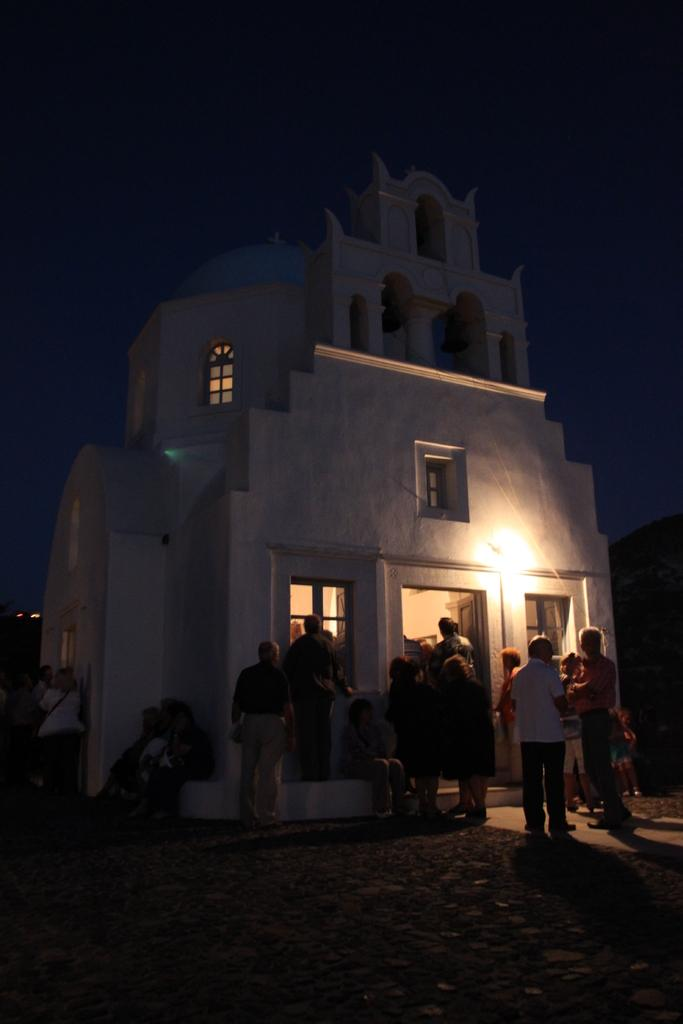What type of structure is in the image? There is a building in the image. What feature can be observed on the building? The building has glass windows. Who is present near the building? There are people standing outside the building. What other structure is near the people? The people are standing near a house. How would you describe the lighting in the image? The sky is dark in the image. What type of vegetable is being used as an alarm in the image? There is no vegetable or alarm present in the image. 